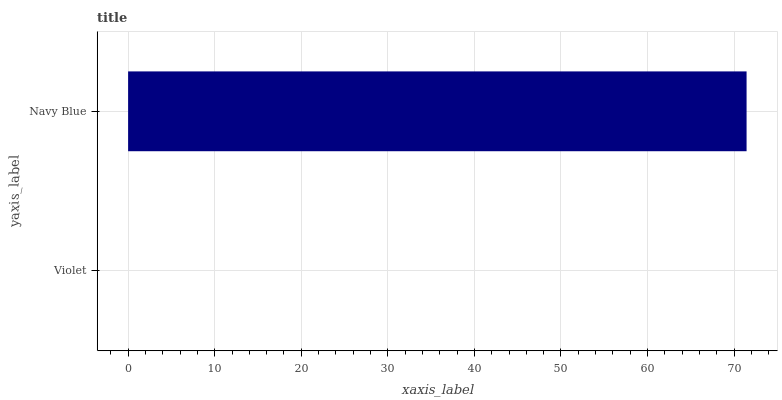Is Violet the minimum?
Answer yes or no. Yes. Is Navy Blue the maximum?
Answer yes or no. Yes. Is Navy Blue the minimum?
Answer yes or no. No. Is Navy Blue greater than Violet?
Answer yes or no. Yes. Is Violet less than Navy Blue?
Answer yes or no. Yes. Is Violet greater than Navy Blue?
Answer yes or no. No. Is Navy Blue less than Violet?
Answer yes or no. No. Is Navy Blue the high median?
Answer yes or no. Yes. Is Violet the low median?
Answer yes or no. Yes. Is Violet the high median?
Answer yes or no. No. Is Navy Blue the low median?
Answer yes or no. No. 